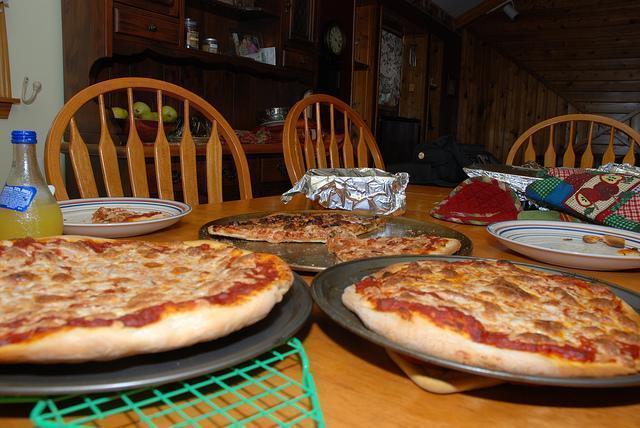The glass drink on the table has what as its primary flavor?
Select the correct answer and articulate reasoning with the following format: 'Answer: answer
Rationale: rationale.'
Options: Citrus, tea, cola, pineapple. Answer: citrus.
Rationale: The drink is orange, not brown or yellow. 